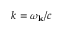Convert formula to latex. <formula><loc_0><loc_0><loc_500><loc_500>k = \omega _ { k } / c</formula> 